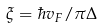<formula> <loc_0><loc_0><loc_500><loc_500>\xi = \hbar { v } _ { F } / \pi \Delta</formula> 